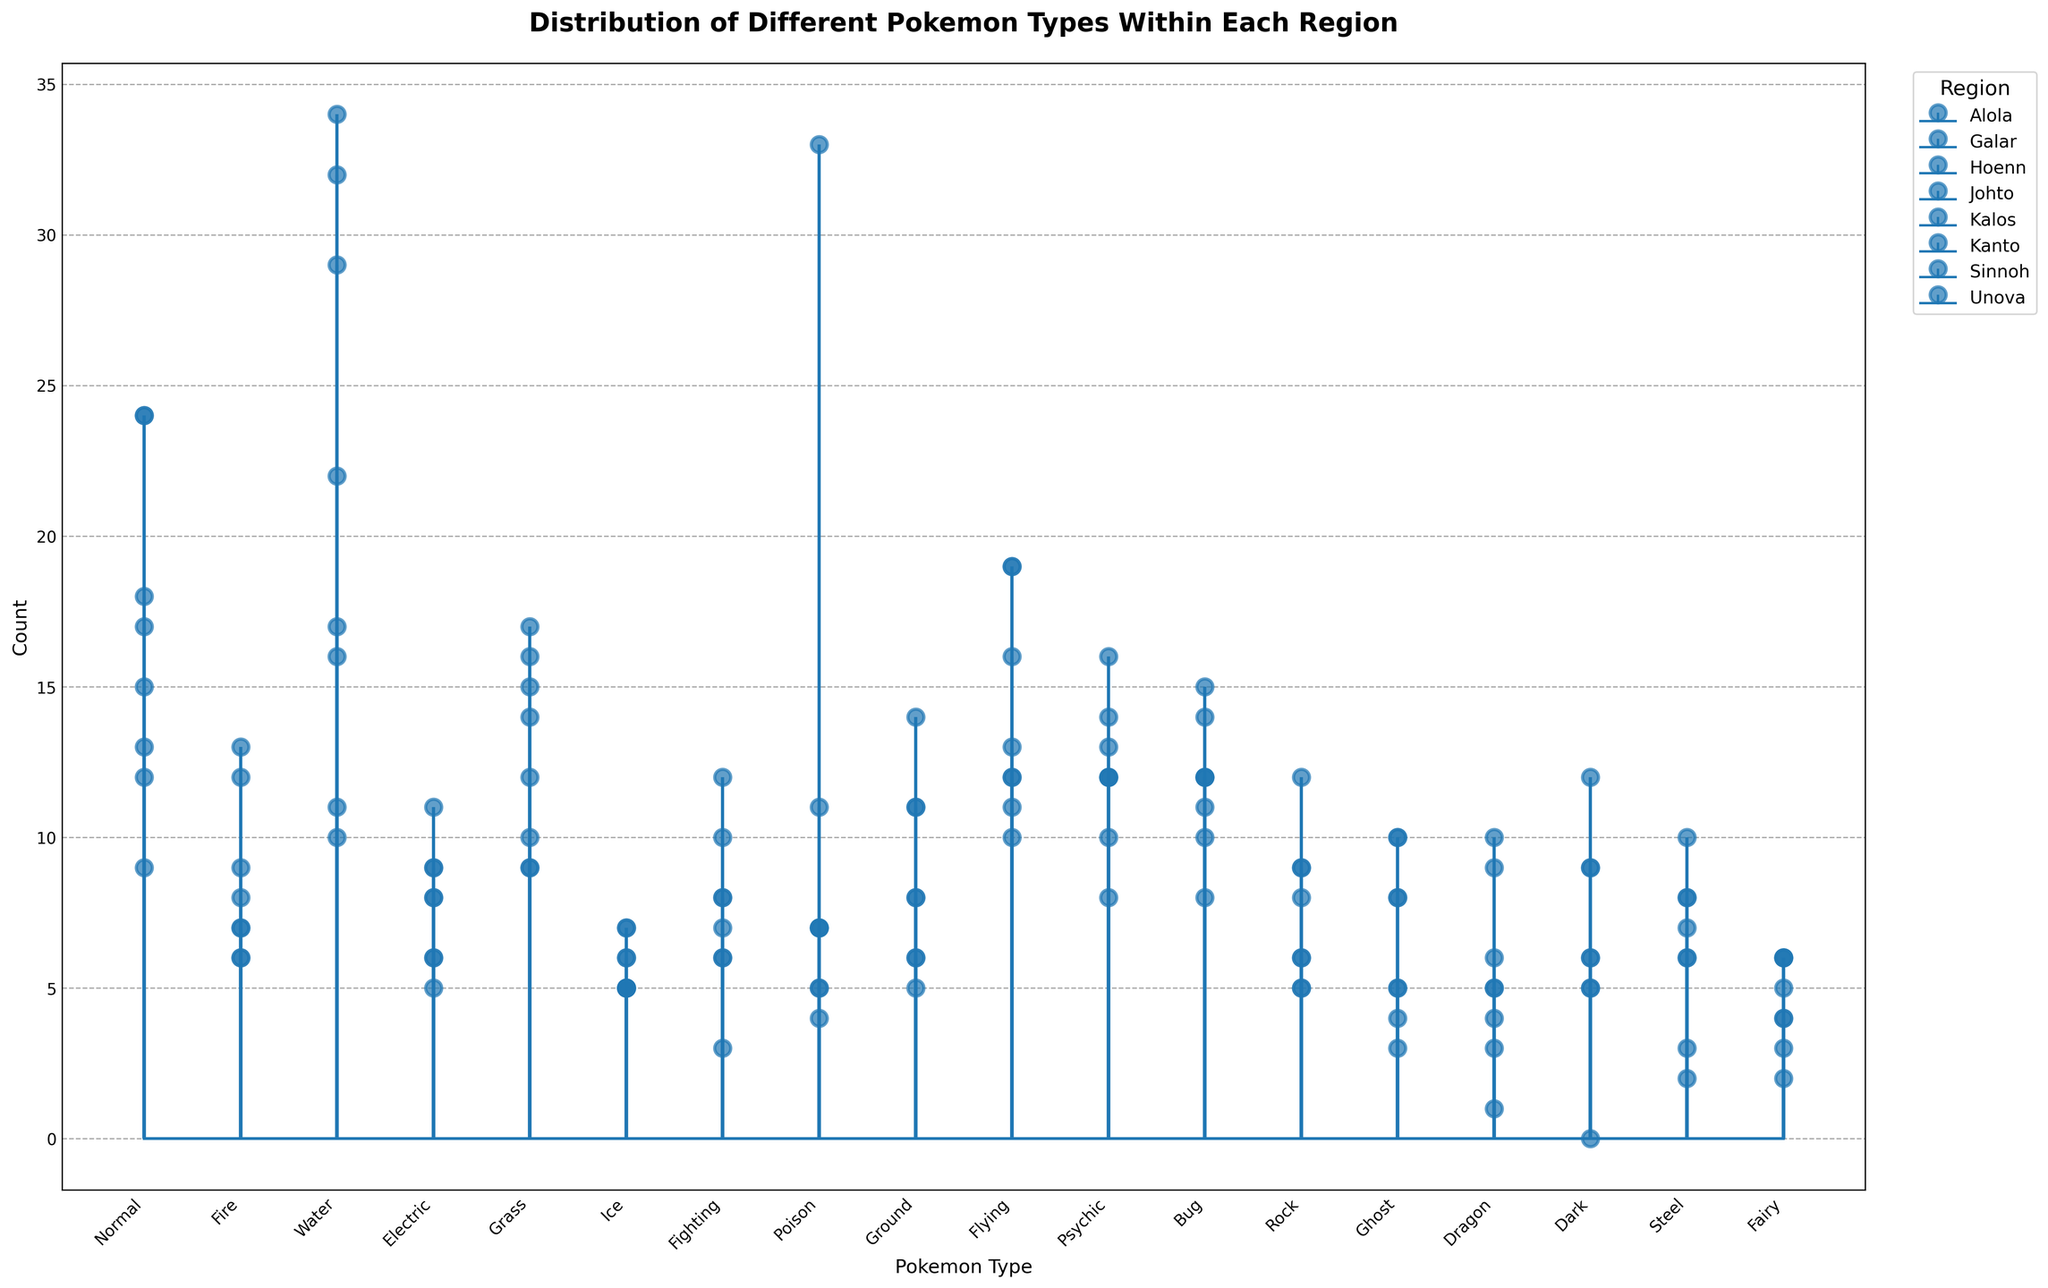Which region has the highest number of Water type Pokemon? To determine the region with the highest number of Water type Pokemon, refer to the height of the stems for the Water type in each region. Hoenn has the tallest stem in this category.
Answer: Hoenn Which region has more Fire type Pokemon, Unova or Kanto? Compare the heights of the stems corresponding to the Fire type Pokemon between Unova and Kanto. Unova has a height of 9 and Kanto has a height of 6.
Answer: Unova Amongst all regions, which Pokemon type is the most prevalent in Kanto? Look for the Pokemon type in Kanto that has the highest stem. The Poison type has the tallest stem in Kanto.
Answer: Poison What's the total number of Psychic type Pokemon across all regions? Sum the count of Psychic type Pokemon from each region: 14 (Kanto) + 10 (Johto) + 16 (Hoenn) + 12 (Sinnoh) + 13 (Unova) + 8 (Kalos) + 12 (Alola) + 12 (Galar). This gives 97.
Answer: 97 Compare the number of Grass type Pokemon in Hoenn and Sinnoh. Which region has more? Compare the heights of the stems for Grass type Pokemon in Hoenn and Sinnoh. Hoenn has a height of 16 whereas Sinnoh has a height of 14.
Answer: Hoenn What's the difference in the number of Flying type Pokemon between Kanto and Johto? Subtract the count of Flying type Pokemon in Johto from that in Kanto. Kanto has 19 and Johto has 13, so the difference is 19 - 13 = 6.
Answer: 6 Which region contains at least one Pokemon of every type and thereby doesn't have zero in any column? Examine the counts for each region to see if any type has zero instances. All types are present in Unova, confirming it.
Answer: Unova How many regions have more than 10 Ghost type Pokemon? Count the number of regions where the stem for Ghost type Pokemon exceeds 10. Unova (10) and Galar (10) meet this criterion.
Answer: 2 Which region has the fewest number of Dragon type Pokemon? Observe the stems for Dragon type Pokemon across regions. Johto has only one, the lowest count.
Answer: Johto Adding the counts of Ice type Pokemon in Kanto, Johto, and Hoenn, what's the total? Sum the counts of Ice type Pokemon from Kanto (5), Johto (5), and Hoenn (6). This sums to 5 + 5 + 6 = 16.
Answer: 16 